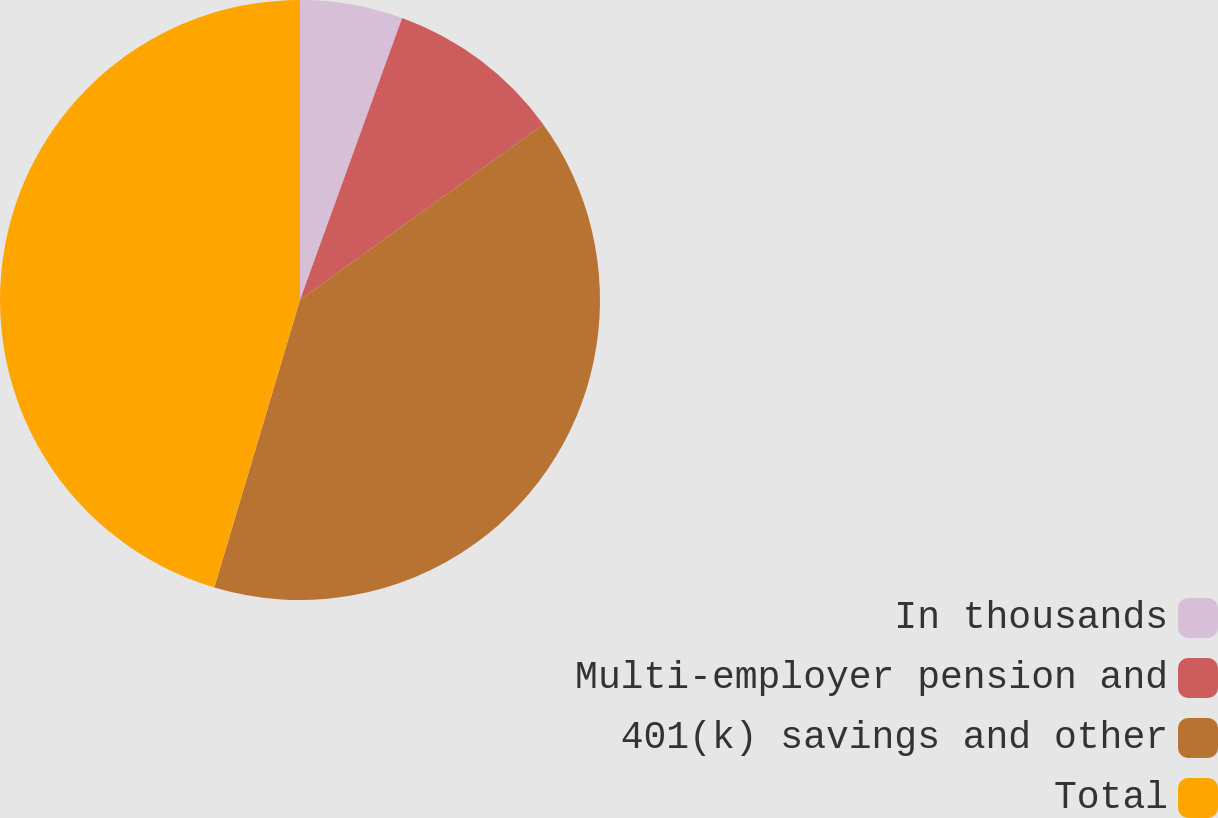Convert chart. <chart><loc_0><loc_0><loc_500><loc_500><pie_chart><fcel>In thousands<fcel>Multi-employer pension and<fcel>401(k) savings and other<fcel>Total<nl><fcel>5.53%<fcel>9.52%<fcel>39.56%<fcel>45.39%<nl></chart> 